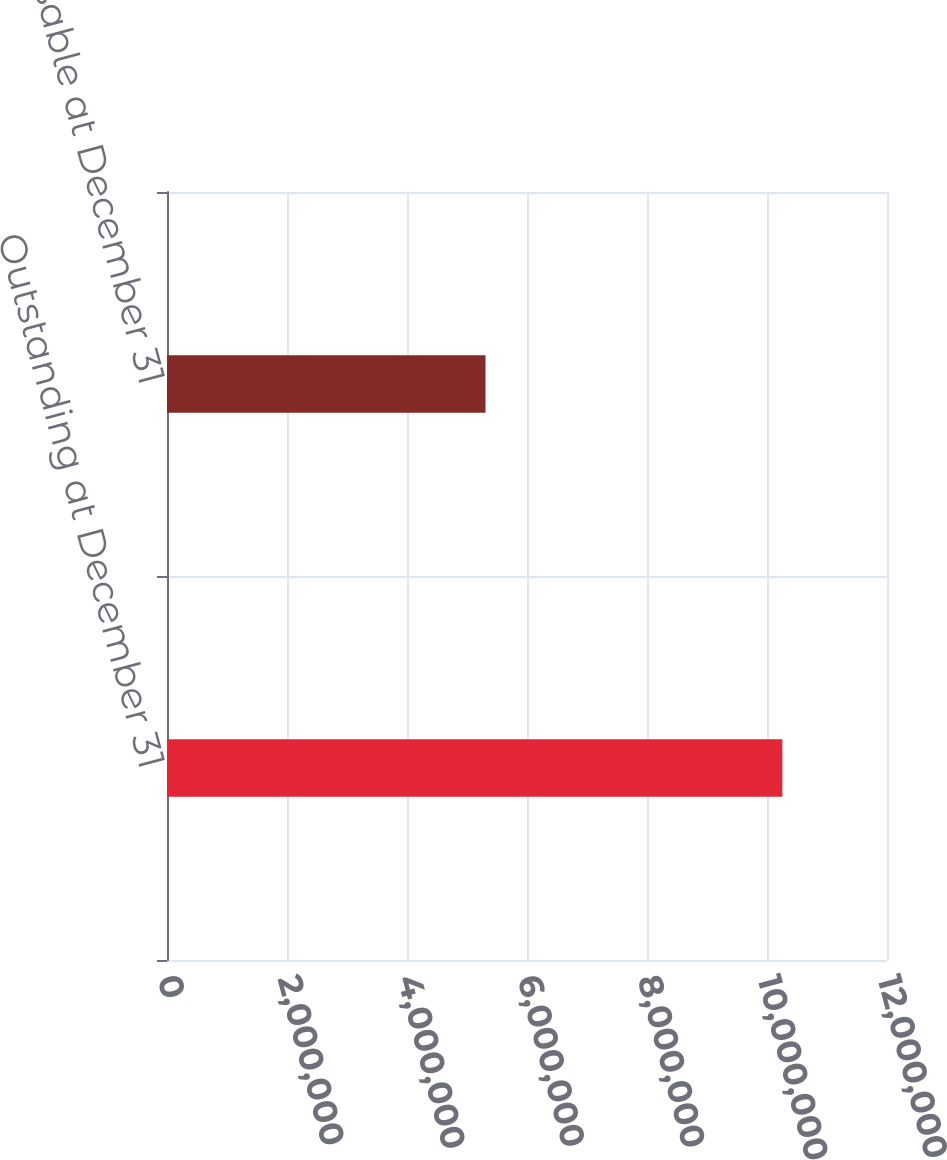<chart> <loc_0><loc_0><loc_500><loc_500><bar_chart><fcel>Outstanding at December 31<fcel>Exercisable at December 31<nl><fcel>1.0256e+07<fcel>5.30846e+06<nl></chart> 